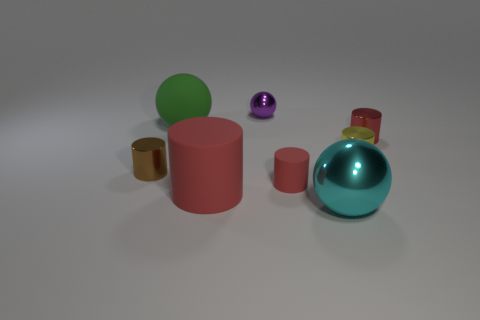How many red cylinders must be subtracted to get 1 red cylinders? 2 Subtract all tiny cylinders. How many cylinders are left? 1 Add 2 cyan metal objects. How many objects exist? 10 Subtract all red cylinders. How many cylinders are left? 2 Subtract all spheres. How many objects are left? 5 Subtract all gray cubes. How many purple spheres are left? 1 Subtract all big green metal spheres. Subtract all big green rubber things. How many objects are left? 7 Add 5 brown things. How many brown things are left? 6 Add 3 tiny green rubber cylinders. How many tiny green rubber cylinders exist? 3 Subtract 0 gray cubes. How many objects are left? 8 